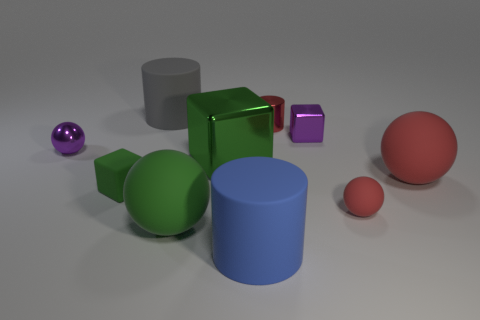Subtract 1 blocks. How many blocks are left? 2 Subtract all tiny rubber blocks. How many blocks are left? 2 Subtract all brown spheres. How many green blocks are left? 2 Subtract all green balls. How many balls are left? 3 Subtract all yellow blocks. Subtract all yellow cylinders. How many blocks are left? 3 Subtract 1 blue cylinders. How many objects are left? 9 Subtract all blocks. How many objects are left? 7 Subtract all metal spheres. Subtract all red objects. How many objects are left? 6 Add 6 tiny shiny blocks. How many tiny shiny blocks are left? 7 Add 1 small green matte cubes. How many small green matte cubes exist? 2 